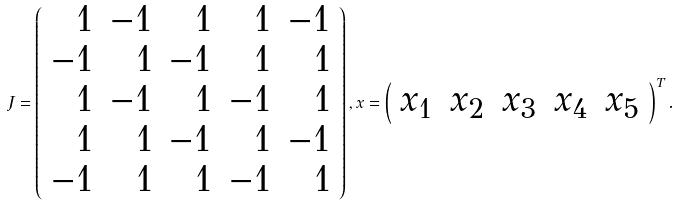<formula> <loc_0><loc_0><loc_500><loc_500>J = \left ( \begin{array} { r r r r r } 1 & - 1 & 1 & 1 & - 1 \\ - 1 & 1 & - 1 & 1 & 1 \\ 1 & - 1 & 1 & - 1 & 1 \\ 1 & 1 & - 1 & 1 & - 1 \\ - 1 & 1 & 1 & - 1 & 1 \end{array} \right ) , x = \left ( \begin{array} { c c c c c } x _ { 1 } & x _ { 2 } & x _ { 3 } & x _ { 4 } & x _ { 5 } \end{array} \right ) ^ { T } .</formula> 